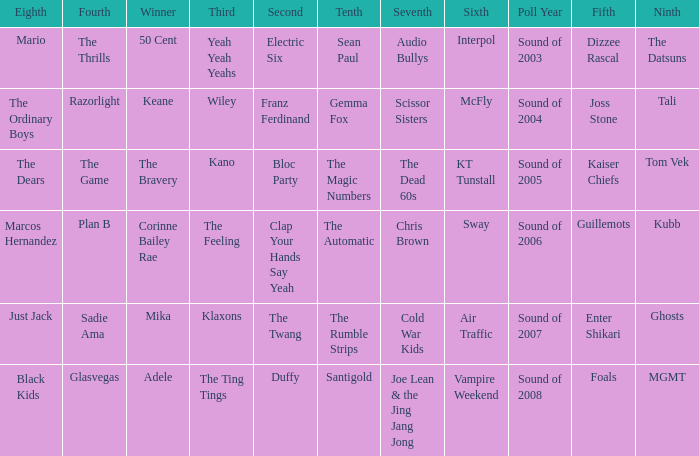Who was in 4th when in 6th is Air Traffic? Sadie Ama. 